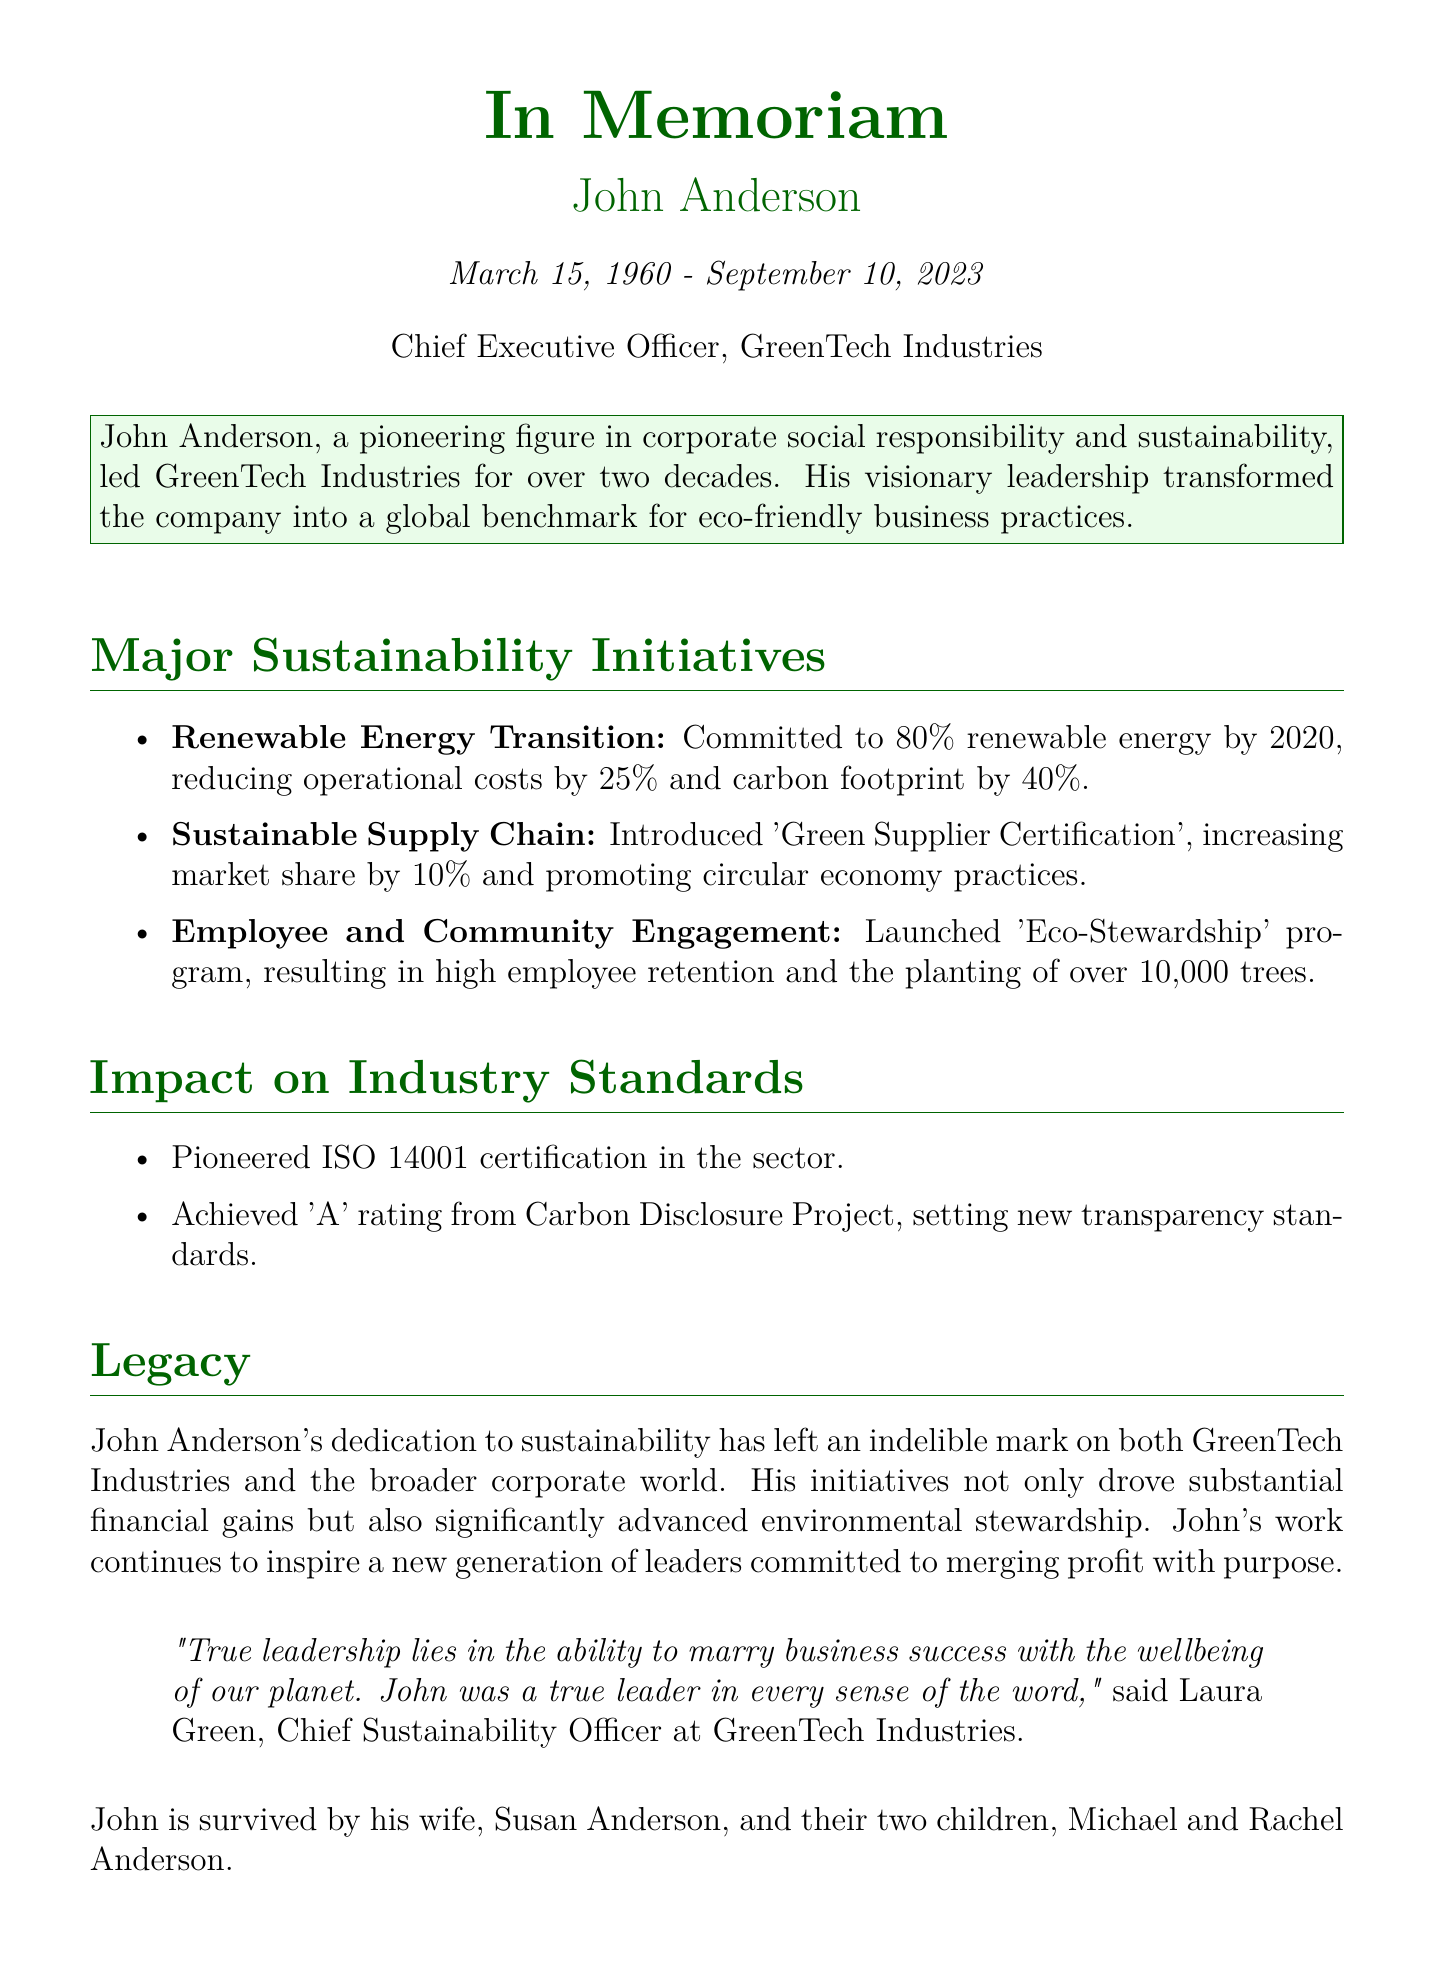What is the name of the corporate executive? The name of the corporate executive being honored in the obituary is John Anderson.
Answer: John Anderson What date did John Anderson pass away? The obituary states that John Anderson passed away on September 10, 2023.
Answer: September 10, 2023 What role did John Anderson hold at GreenTech Industries? John Anderson served as the Chief Executive Officer of GreenTech Industries.
Answer: Chief Executive Officer What percentage of renewable energy did John Anderson commit to by 2020? The document mentions a commitment to 80% renewable energy by 2020.
Answer: 80% How much did the operational costs reduce due to the renewable energy transition? The text indicates that operational costs were reduced by 25% as a result of this transition.
Answer: 25% What program did John Anderson launch for employee and community engagement? The program mentioned in the obituary is called 'Eco-Stewardship'.
Answer: Eco-Stewardship How many trees were planted through the Eco-Stewardship program? The document states that over 10,000 trees were planted as part of this initiative.
Answer: over 10,000 What certification did John Anderson's initiatives help pioneer in the sector? The obituary states that he pioneered ISO 14001 certification in the sector.
Answer: ISO 14001 Who quoted about John Anderson's leadership? The quote about John Anderson's leadership was made by Laura Green, Chief Sustainability Officer at GreenTech Industries.
Answer: Laura Green 